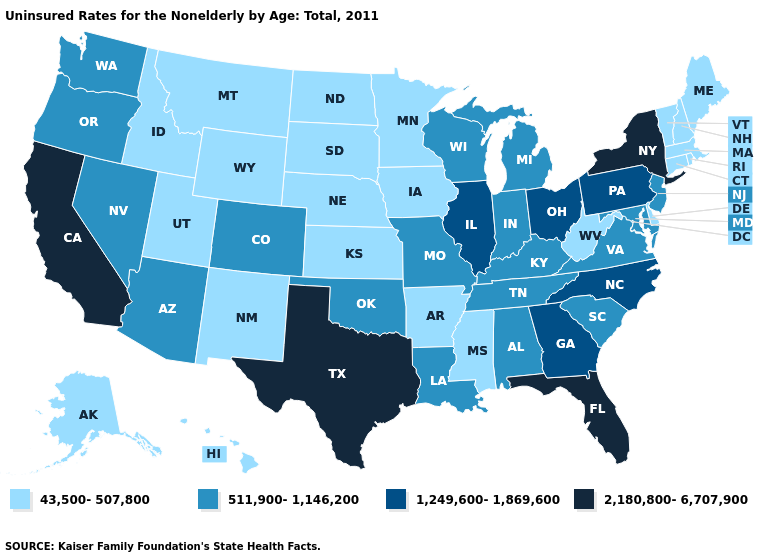What is the value of Colorado?
Write a very short answer. 511,900-1,146,200. Among the states that border Pennsylvania , does West Virginia have the highest value?
Be succinct. No. Does California have the highest value in the USA?
Keep it brief. Yes. Among the states that border Colorado , does Oklahoma have the lowest value?
Concise answer only. No. Among the states that border Arkansas , which have the lowest value?
Give a very brief answer. Mississippi. How many symbols are there in the legend?
Be succinct. 4. What is the value of Michigan?
Write a very short answer. 511,900-1,146,200. Which states have the lowest value in the South?
Concise answer only. Arkansas, Delaware, Mississippi, West Virginia. Name the states that have a value in the range 2,180,800-6,707,900?
Be succinct. California, Florida, New York, Texas. Name the states that have a value in the range 1,249,600-1,869,600?
Be succinct. Georgia, Illinois, North Carolina, Ohio, Pennsylvania. Does California have the highest value in the USA?
Answer briefly. Yes. Is the legend a continuous bar?
Give a very brief answer. No. What is the value of Kentucky?
Give a very brief answer. 511,900-1,146,200. What is the value of California?
Concise answer only. 2,180,800-6,707,900. Which states hav the highest value in the Northeast?
Concise answer only. New York. 